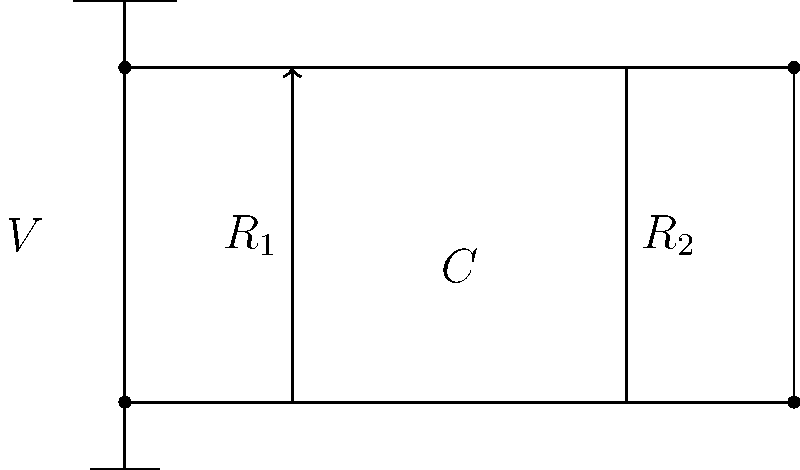In the circuit diagram shown, resistors $R_1$ and $R_2$ are connected in series with a capacitor $C$. If the voltage source $V$ supplies a constant DC voltage, what will be the voltage across the capacitor $C$ after a long time? To solve this problem, let's follow these steps:

1. Understand the behavior of capacitors in DC circuits:
   - In DC circuits, capacitors act as open circuits after a long time.
   - They charge up to the applied voltage and then stop conducting current.

2. Analyze the circuit:
   - The resistors and capacitor are in series.
   - In a series circuit, the same current flows through all components.

3. Consider the long-term behavior:
   - After a long time, the capacitor will be fully charged.
   - No current will flow through the circuit.

4. Apply voltage division principle:
   - In a fully charged state, the capacitor acts like an open circuit.
   - This means all the voltage from the source will appear across the capacitor.

5. Conclude:
   - The voltage across the capacitor will be equal to the source voltage $V$.

Therefore, after a long time, the voltage across the capacitor $C$ will be equal to the supply voltage $V$.
Answer: $V$ 